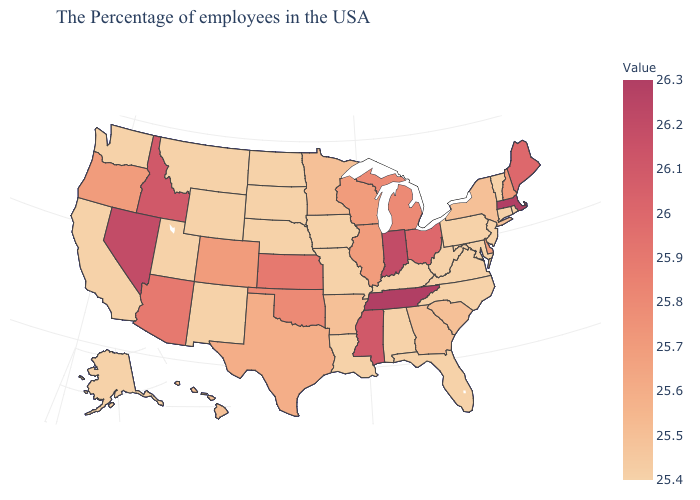Does Washington have a lower value than Texas?
Quick response, please. Yes. Does Louisiana have a lower value than Oklahoma?
Concise answer only. Yes. Among the states that border Rhode Island , which have the highest value?
Quick response, please. Massachusetts. Is the legend a continuous bar?
Write a very short answer. Yes. 